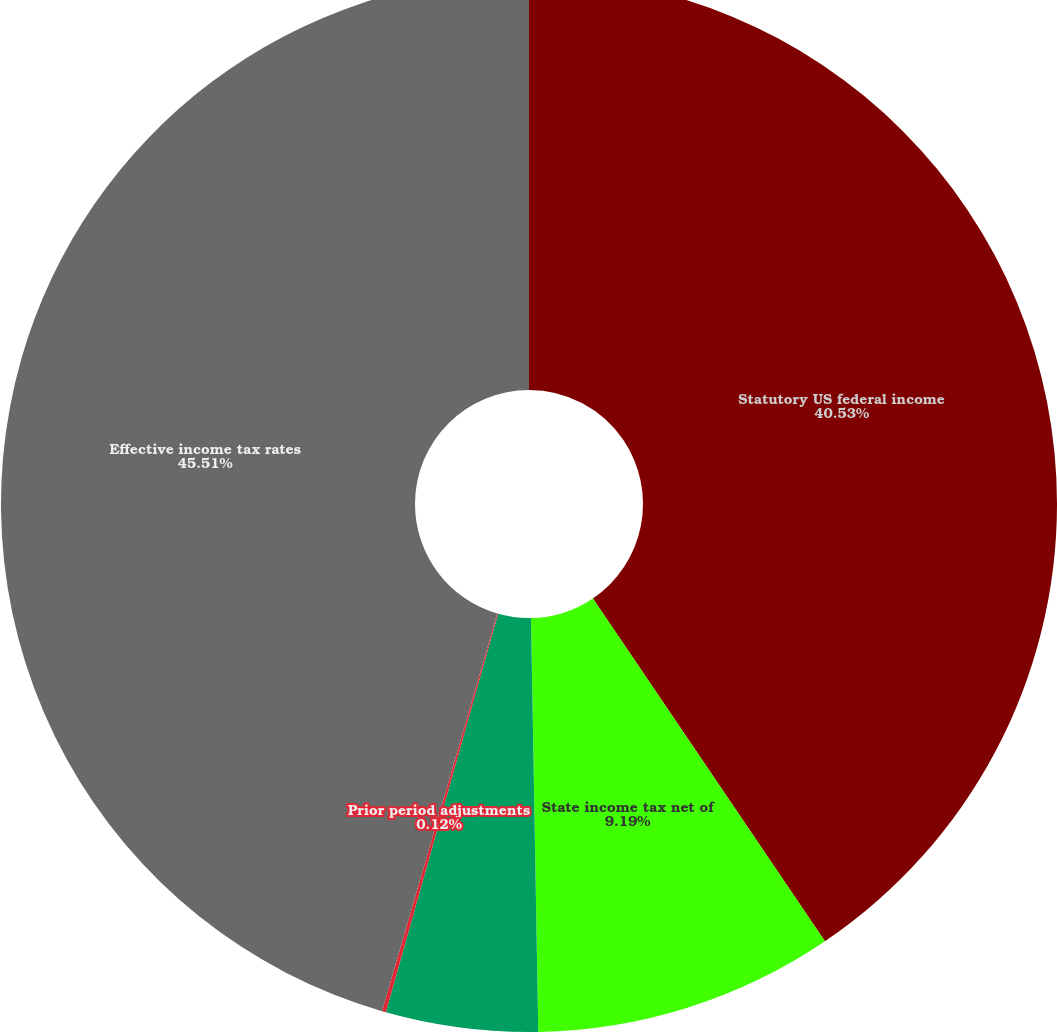Convert chart to OTSL. <chart><loc_0><loc_0><loc_500><loc_500><pie_chart><fcel>Statutory US federal income<fcel>State income tax net of<fcel>Valuation allowance<fcel>Prior period adjustments<fcel>Effective income tax rates<nl><fcel>40.53%<fcel>9.19%<fcel>4.65%<fcel>0.12%<fcel>45.51%<nl></chart> 